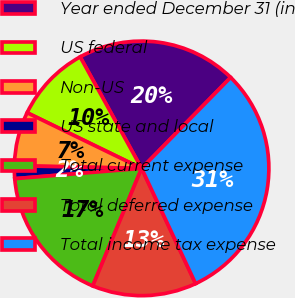<chart> <loc_0><loc_0><loc_500><loc_500><pie_chart><fcel>Year ended December 31 (in<fcel>US federal<fcel>Non-US<fcel>US state and local<fcel>Total current expense<fcel>Total deferred expense<fcel>Total income tax expense<nl><fcel>20.35%<fcel>9.78%<fcel>6.87%<fcel>1.62%<fcel>17.44%<fcel>13.24%<fcel>30.69%<nl></chart> 